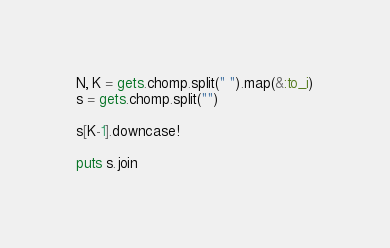<code> <loc_0><loc_0><loc_500><loc_500><_Ruby_>N, K = gets.chomp.split(" ").map(&:to_i)
s = gets.chomp.split("")

s[K-1].downcase!

puts s.join</code> 